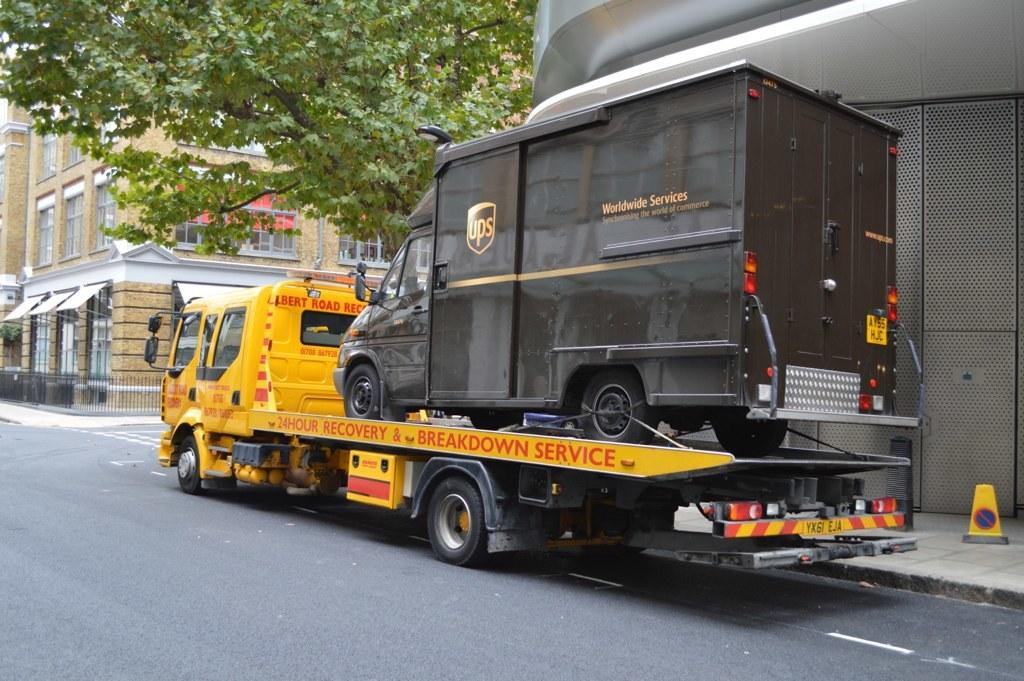What type of structure is located on the right side of the image? There is a building with windows on the right side of the image. What natural element can be seen in the image? There is a tree in the image. What type of vehicles are present in the image? There are yellow and black color vehicles in the image. Where are the vehicles located in the image? The vehicles are on a road. Can you hear the owl hooting in the image? There is no owl present in the image, so it is not possible to hear it hooting. What is the texture of the tree bark in the image? The texture of the tree bark cannot be determined from the image, as it only provides visual information. 